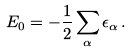<formula> <loc_0><loc_0><loc_500><loc_500>E _ { 0 } = - \frac { 1 } { 2 } \sum _ { \alpha } \epsilon _ { \alpha } \, .</formula> 